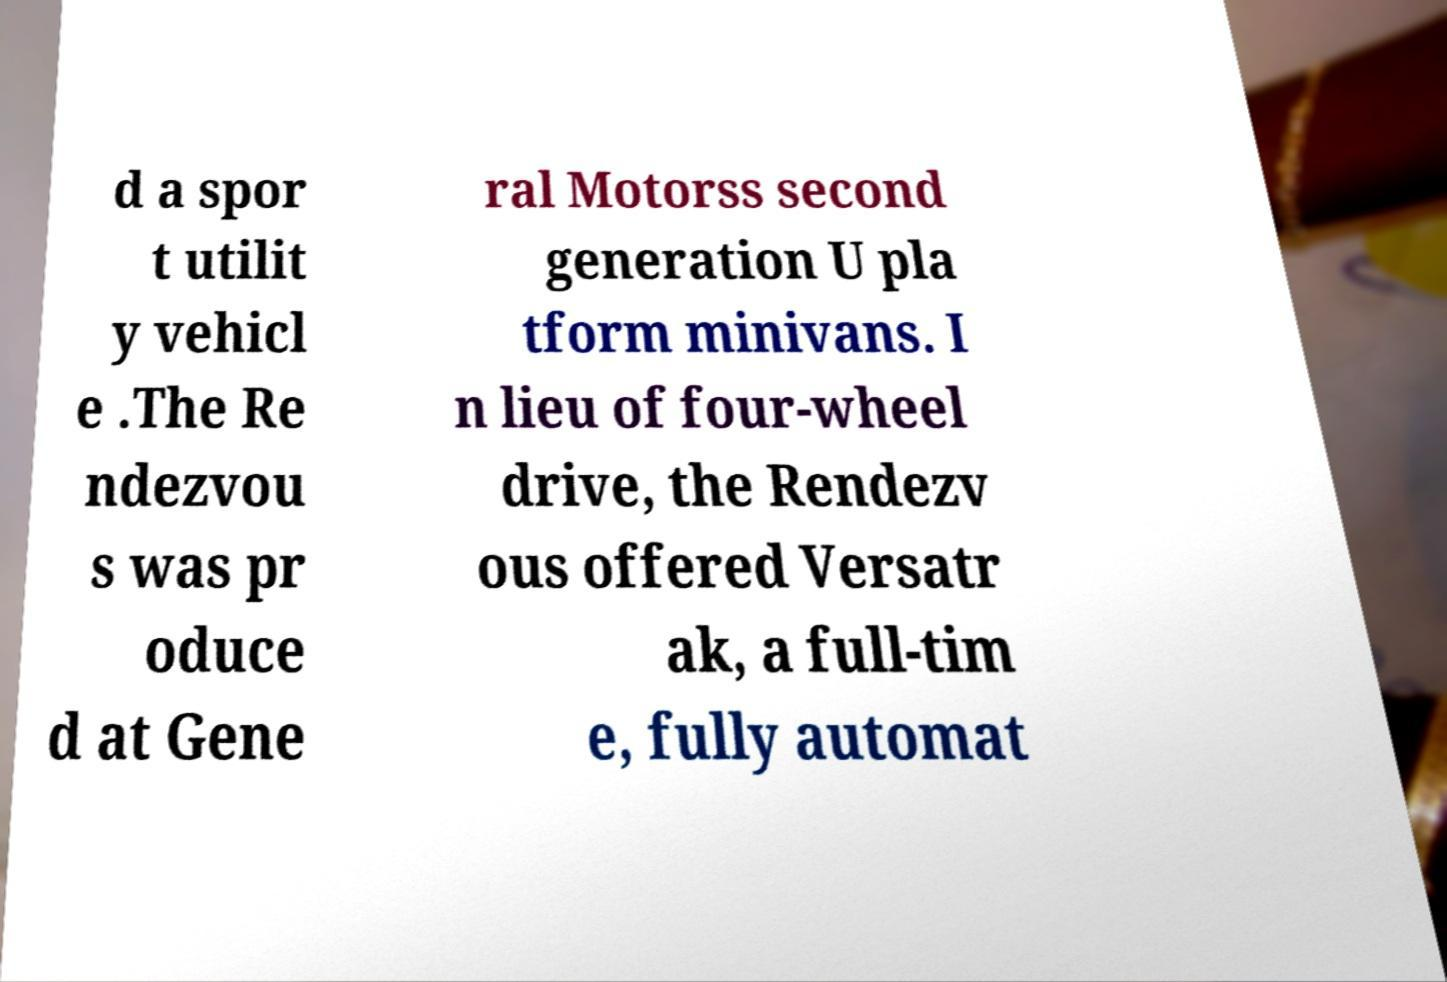For documentation purposes, I need the text within this image transcribed. Could you provide that? d a spor t utilit y vehicl e .The Re ndezvou s was pr oduce d at Gene ral Motorss second generation U pla tform minivans. I n lieu of four-wheel drive, the Rendezv ous offered Versatr ak, a full-tim e, fully automat 